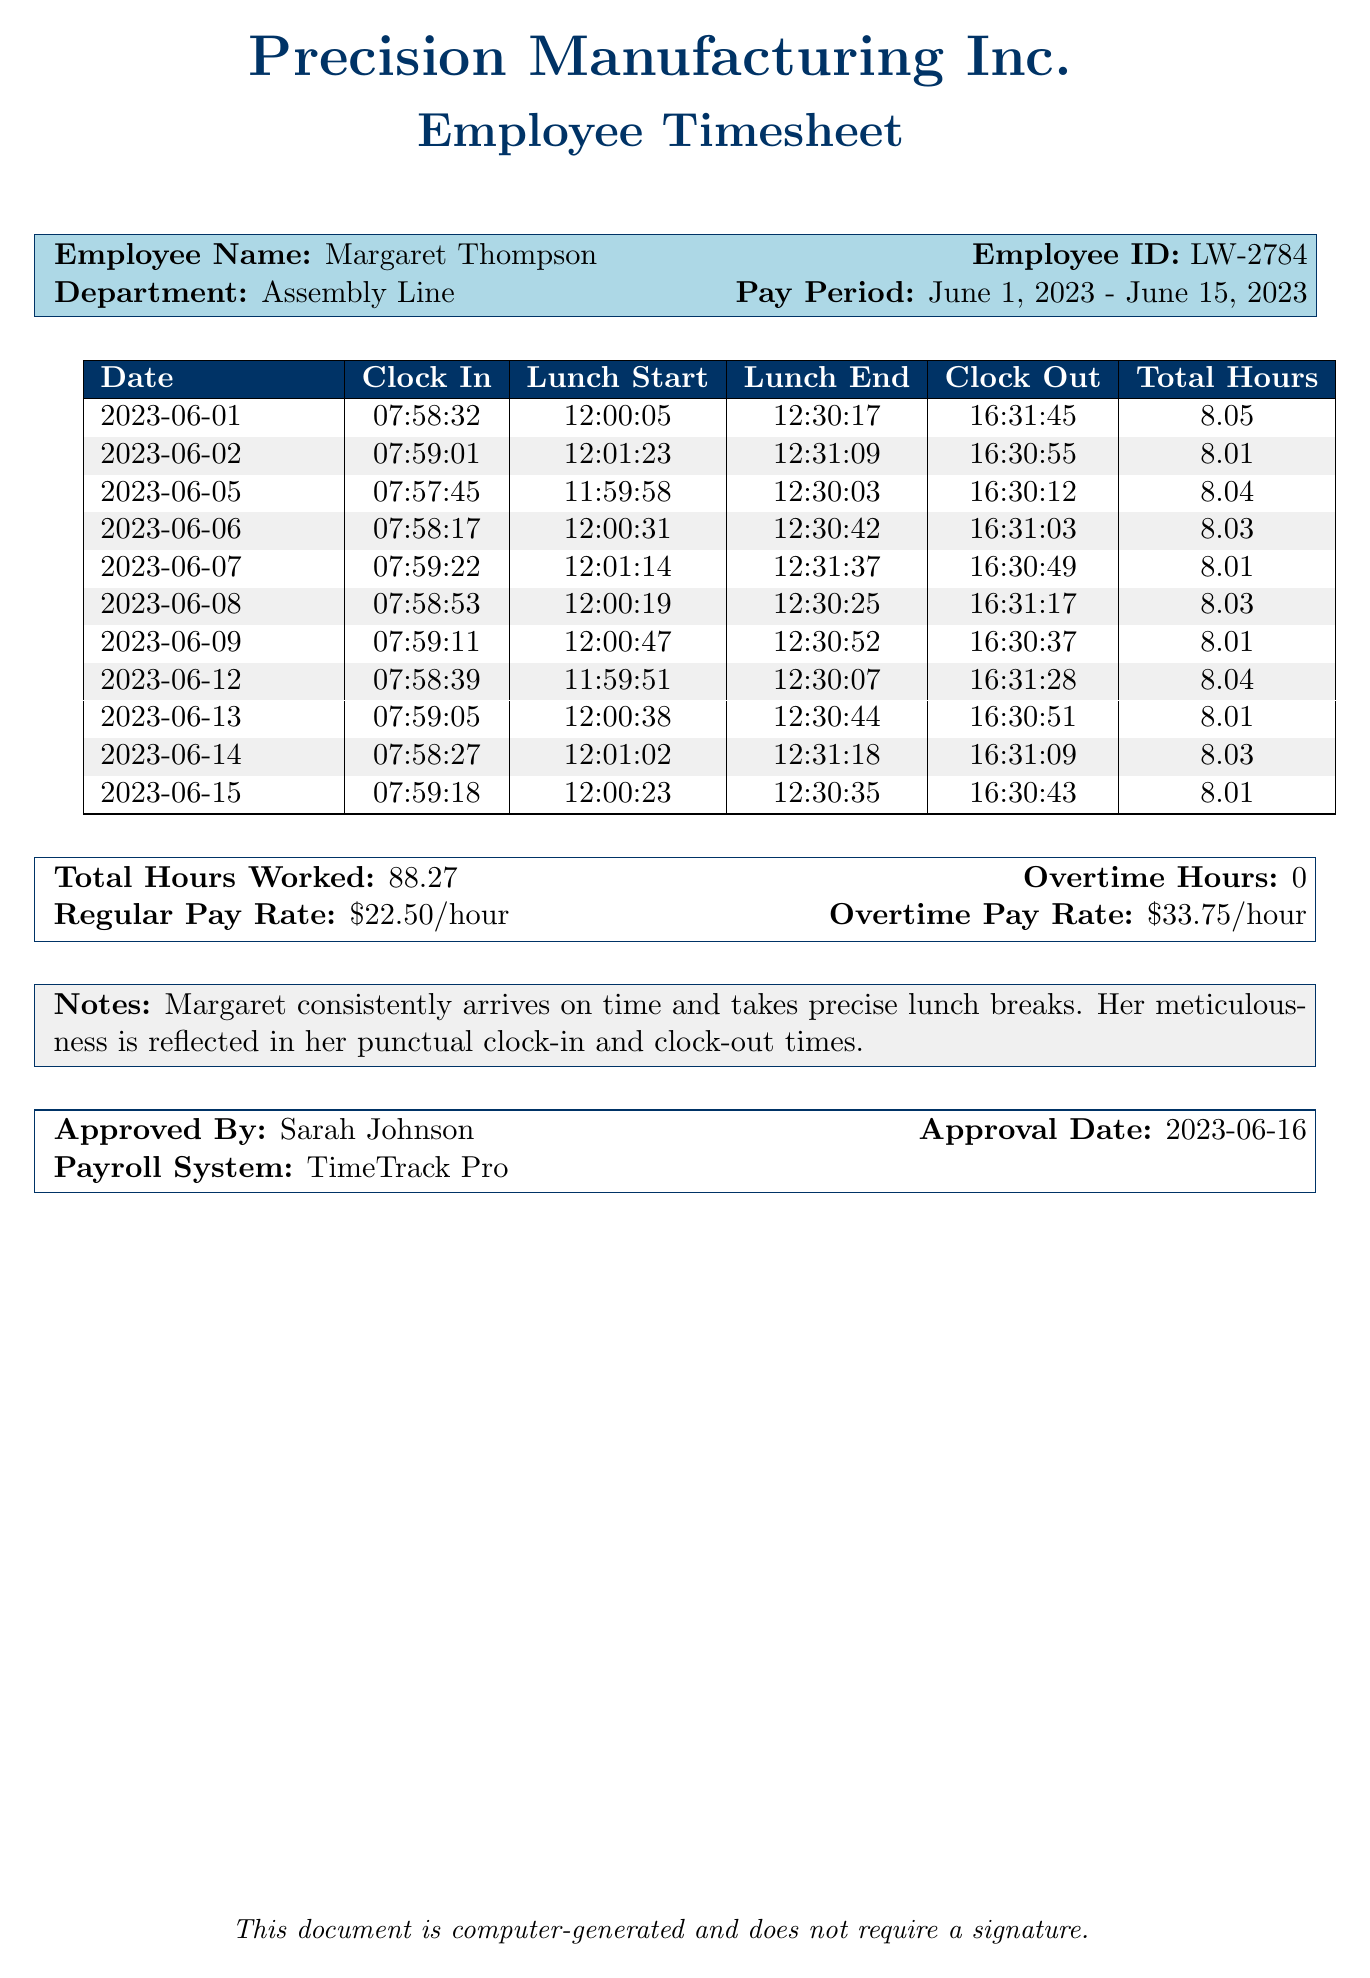what is the employee name? The employee name is clearly stated at the beginning of the document under "Employee Name."
Answer: Margaret Thompson what is the pay period? The pay period is specified in the timesheet section of the document.
Answer: June 1, 2023 - June 15, 2023 how many total hours worked are listed? The total hours worked are summarized toward the end of the document.
Answer: 88.27 who approved the timesheet? The approver's name is provided in the section labeled "Approved By."
Answer: Sarah Johnson what is the regular pay rate? The regular pay rate is indicated in the payroll information at the bottom of the document.
Answer: $22.50/hour how many days are included in the timesheet? The timesheet includes entries dated within the specified pay period, which encompasses two weeks.
Answer: 11 which department does the employee work in? The department is indicated alongside the employee's name and ID.
Answer: Assembly Line what is the overtime hours reported? The overtime hours are summarized in the payroll information section of the document.
Answer: 0 when was the timesheet approved? The approval date is noted in the section that includes the approver's details.
Answer: 2023-06-16 